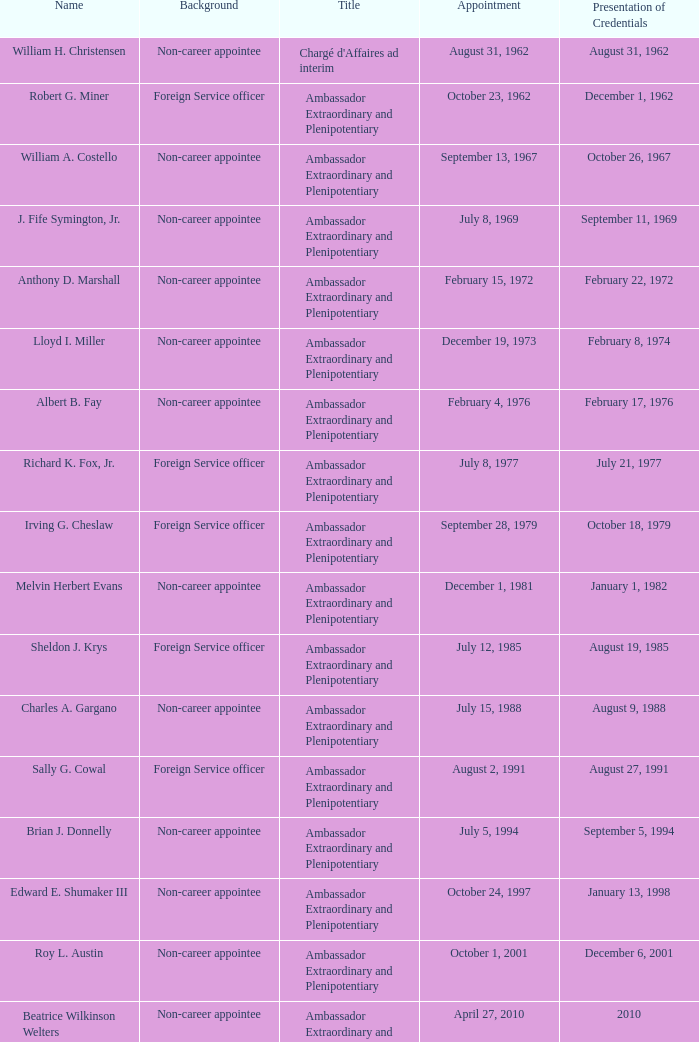When was William A. Costello appointed? September 13, 1967. 